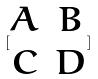Convert formula to latex. <formula><loc_0><loc_0><loc_500><loc_500>[ \begin{matrix} A & B \\ C & D \end{matrix} ]</formula> 